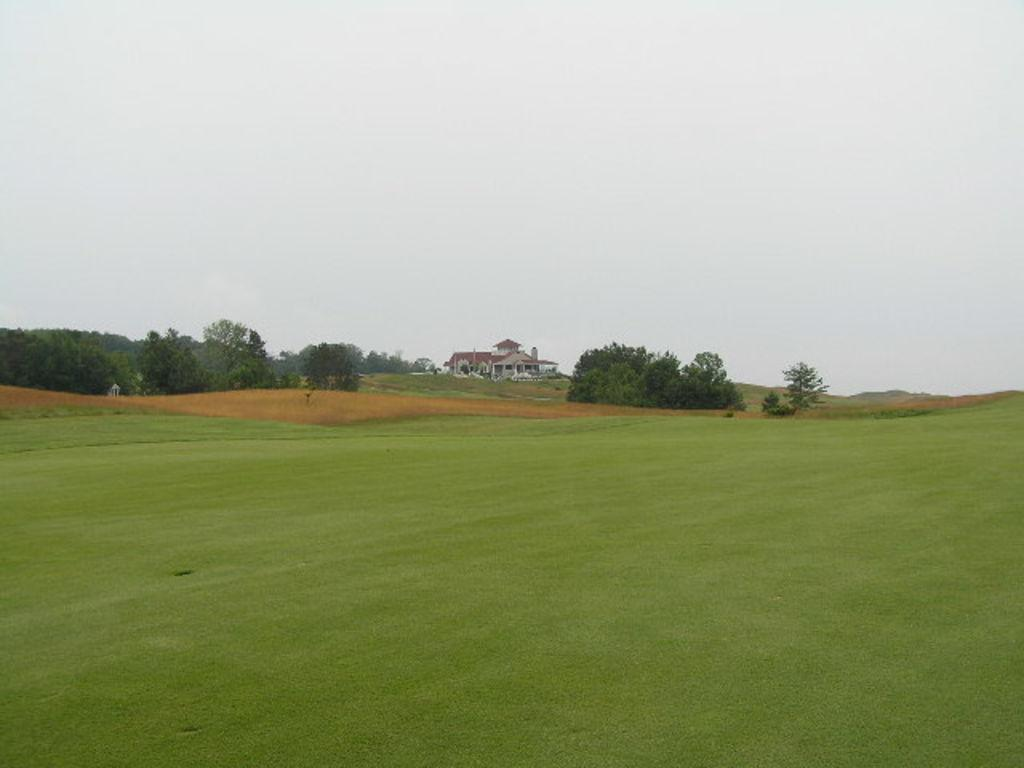What type of vegetation can be seen in the image? There is grass and trees in the image. What type of structure is present in the image? There is a building in the image. What can be seen in the background of the image? The sky is visible in the background of the image. What type of duck is sitting on the car in the image? There is no duck or car present in the image. What is being served for lunch in the image? There is no reference to lunch or any food in the image. 